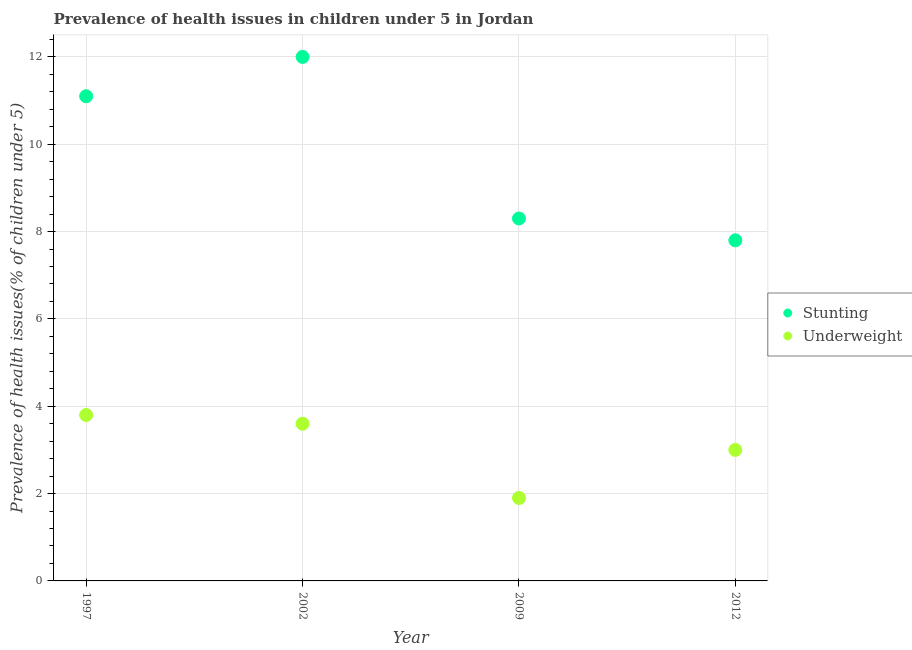How many different coloured dotlines are there?
Provide a short and direct response. 2. Is the number of dotlines equal to the number of legend labels?
Make the answer very short. Yes. What is the percentage of underweight children in 1997?
Make the answer very short. 3.8. Across all years, what is the maximum percentage of underweight children?
Provide a succinct answer. 3.8. Across all years, what is the minimum percentage of underweight children?
Your answer should be very brief. 1.9. In which year was the percentage of stunted children maximum?
Make the answer very short. 2002. In which year was the percentage of stunted children minimum?
Offer a very short reply. 2012. What is the total percentage of underweight children in the graph?
Provide a short and direct response. 12.3. What is the difference between the percentage of underweight children in 1997 and that in 2002?
Ensure brevity in your answer.  0.2. What is the difference between the percentage of stunted children in 1997 and the percentage of underweight children in 2002?
Keep it short and to the point. 7.5. What is the average percentage of stunted children per year?
Offer a terse response. 9.8. In the year 2002, what is the difference between the percentage of underweight children and percentage of stunted children?
Offer a very short reply. -8.4. In how many years, is the percentage of underweight children greater than 7.2 %?
Give a very brief answer. 0. What is the ratio of the percentage of underweight children in 2009 to that in 2012?
Your answer should be compact. 0.63. What is the difference between the highest and the second highest percentage of stunted children?
Offer a very short reply. 0.9. What is the difference between the highest and the lowest percentage of stunted children?
Ensure brevity in your answer.  4.2. Is the sum of the percentage of stunted children in 1997 and 2009 greater than the maximum percentage of underweight children across all years?
Ensure brevity in your answer.  Yes. Is the percentage of underweight children strictly less than the percentage of stunted children over the years?
Your answer should be very brief. Yes. What is the difference between two consecutive major ticks on the Y-axis?
Ensure brevity in your answer.  2. Are the values on the major ticks of Y-axis written in scientific E-notation?
Offer a very short reply. No. Where does the legend appear in the graph?
Provide a succinct answer. Center right. How many legend labels are there?
Ensure brevity in your answer.  2. How are the legend labels stacked?
Keep it short and to the point. Vertical. What is the title of the graph?
Provide a short and direct response. Prevalence of health issues in children under 5 in Jordan. What is the label or title of the Y-axis?
Ensure brevity in your answer.  Prevalence of health issues(% of children under 5). What is the Prevalence of health issues(% of children under 5) in Stunting in 1997?
Provide a short and direct response. 11.1. What is the Prevalence of health issues(% of children under 5) of Underweight in 1997?
Make the answer very short. 3.8. What is the Prevalence of health issues(% of children under 5) of Stunting in 2002?
Offer a very short reply. 12. What is the Prevalence of health issues(% of children under 5) of Underweight in 2002?
Give a very brief answer. 3.6. What is the Prevalence of health issues(% of children under 5) in Stunting in 2009?
Your response must be concise. 8.3. What is the Prevalence of health issues(% of children under 5) in Underweight in 2009?
Provide a short and direct response. 1.9. What is the Prevalence of health issues(% of children under 5) of Stunting in 2012?
Offer a terse response. 7.8. Across all years, what is the maximum Prevalence of health issues(% of children under 5) in Stunting?
Keep it short and to the point. 12. Across all years, what is the maximum Prevalence of health issues(% of children under 5) in Underweight?
Your answer should be compact. 3.8. Across all years, what is the minimum Prevalence of health issues(% of children under 5) of Stunting?
Offer a very short reply. 7.8. Across all years, what is the minimum Prevalence of health issues(% of children under 5) of Underweight?
Your answer should be compact. 1.9. What is the total Prevalence of health issues(% of children under 5) in Stunting in the graph?
Ensure brevity in your answer.  39.2. What is the difference between the Prevalence of health issues(% of children under 5) of Stunting in 1997 and that in 2002?
Provide a succinct answer. -0.9. What is the difference between the Prevalence of health issues(% of children under 5) of Stunting in 1997 and that in 2009?
Offer a terse response. 2.8. What is the difference between the Prevalence of health issues(% of children under 5) of Underweight in 1997 and that in 2009?
Give a very brief answer. 1.9. What is the difference between the Prevalence of health issues(% of children under 5) of Stunting in 1997 and that in 2012?
Ensure brevity in your answer.  3.3. What is the difference between the Prevalence of health issues(% of children under 5) in Stunting in 2002 and that in 2009?
Your answer should be compact. 3.7. What is the difference between the Prevalence of health issues(% of children under 5) of Underweight in 2002 and that in 2009?
Give a very brief answer. 1.7. What is the difference between the Prevalence of health issues(% of children under 5) in Stunting in 1997 and the Prevalence of health issues(% of children under 5) in Underweight in 2012?
Make the answer very short. 8.1. What is the difference between the Prevalence of health issues(% of children under 5) of Stunting in 2002 and the Prevalence of health issues(% of children under 5) of Underweight in 2009?
Your response must be concise. 10.1. What is the difference between the Prevalence of health issues(% of children under 5) in Stunting in 2002 and the Prevalence of health issues(% of children under 5) in Underweight in 2012?
Provide a succinct answer. 9. What is the difference between the Prevalence of health issues(% of children under 5) in Stunting in 2009 and the Prevalence of health issues(% of children under 5) in Underweight in 2012?
Give a very brief answer. 5.3. What is the average Prevalence of health issues(% of children under 5) of Underweight per year?
Keep it short and to the point. 3.08. In the year 1997, what is the difference between the Prevalence of health issues(% of children under 5) in Stunting and Prevalence of health issues(% of children under 5) in Underweight?
Provide a short and direct response. 7.3. In the year 2002, what is the difference between the Prevalence of health issues(% of children under 5) in Stunting and Prevalence of health issues(% of children under 5) in Underweight?
Your answer should be very brief. 8.4. What is the ratio of the Prevalence of health issues(% of children under 5) in Stunting in 1997 to that in 2002?
Your answer should be very brief. 0.93. What is the ratio of the Prevalence of health issues(% of children under 5) in Underweight in 1997 to that in 2002?
Your response must be concise. 1.06. What is the ratio of the Prevalence of health issues(% of children under 5) of Stunting in 1997 to that in 2009?
Give a very brief answer. 1.34. What is the ratio of the Prevalence of health issues(% of children under 5) in Underweight in 1997 to that in 2009?
Provide a short and direct response. 2. What is the ratio of the Prevalence of health issues(% of children under 5) of Stunting in 1997 to that in 2012?
Your answer should be compact. 1.42. What is the ratio of the Prevalence of health issues(% of children under 5) in Underweight in 1997 to that in 2012?
Your answer should be compact. 1.27. What is the ratio of the Prevalence of health issues(% of children under 5) in Stunting in 2002 to that in 2009?
Your response must be concise. 1.45. What is the ratio of the Prevalence of health issues(% of children under 5) in Underweight in 2002 to that in 2009?
Your answer should be very brief. 1.89. What is the ratio of the Prevalence of health issues(% of children under 5) in Stunting in 2002 to that in 2012?
Provide a short and direct response. 1.54. What is the ratio of the Prevalence of health issues(% of children under 5) of Stunting in 2009 to that in 2012?
Ensure brevity in your answer.  1.06. What is the ratio of the Prevalence of health issues(% of children under 5) in Underweight in 2009 to that in 2012?
Offer a very short reply. 0.63. What is the difference between the highest and the lowest Prevalence of health issues(% of children under 5) in Stunting?
Offer a very short reply. 4.2. What is the difference between the highest and the lowest Prevalence of health issues(% of children under 5) in Underweight?
Ensure brevity in your answer.  1.9. 